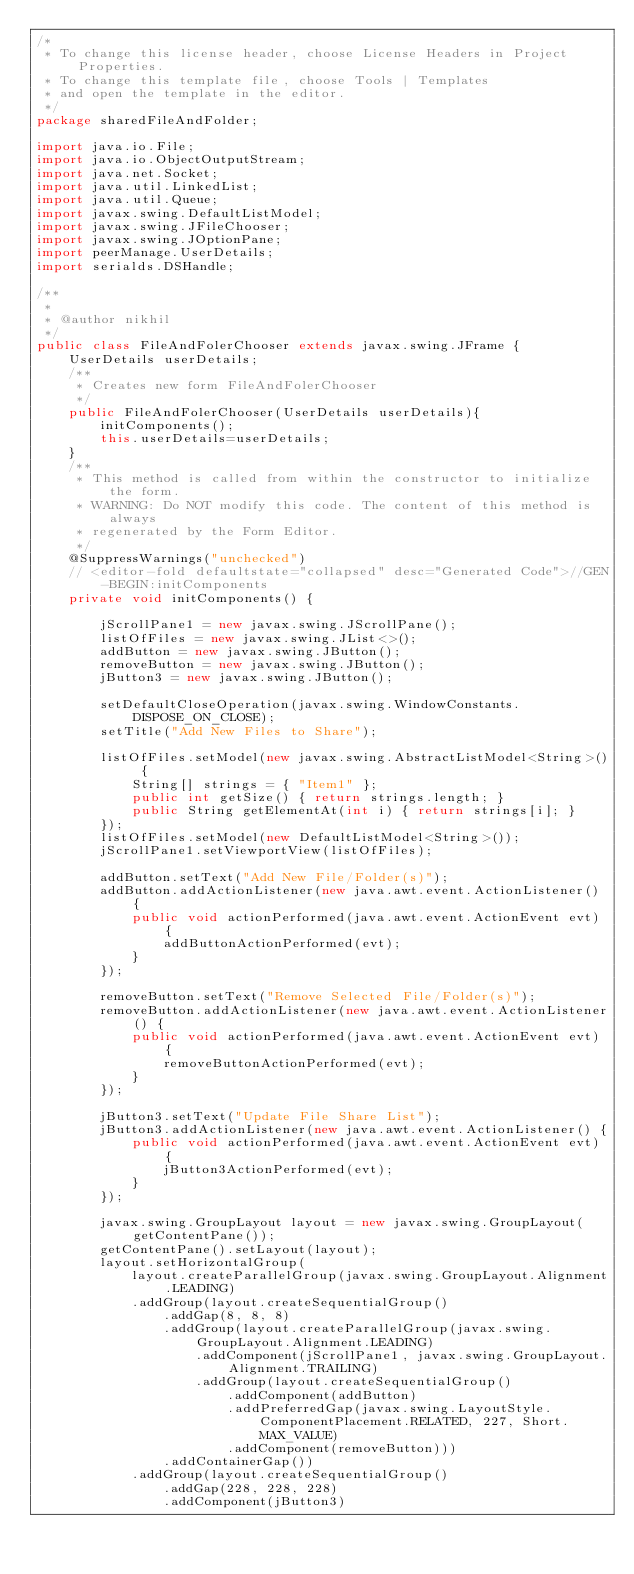Convert code to text. <code><loc_0><loc_0><loc_500><loc_500><_Java_>/*
 * To change this license header, choose License Headers in Project Properties.
 * To change this template file, choose Tools | Templates
 * and open the template in the editor.
 */
package sharedFileAndFolder;

import java.io.File;
import java.io.ObjectOutputStream;
import java.net.Socket;
import java.util.LinkedList;
import java.util.Queue;
import javax.swing.DefaultListModel;
import javax.swing.JFileChooser;
import javax.swing.JOptionPane;
import peerManage.UserDetails;
import serialds.DSHandle;

/**
 *
 * @author nikhil
 */
public class FileAndFolerChooser extends javax.swing.JFrame {
    UserDetails userDetails;
    /**
     * Creates new form FileAndFolerChooser
     */
    public FileAndFolerChooser(UserDetails userDetails){
        initComponents();
        this.userDetails=userDetails;
    }
    /**
     * This method is called from within the constructor to initialize the form.
     * WARNING: Do NOT modify this code. The content of this method is always
     * regenerated by the Form Editor.
     */
    @SuppressWarnings("unchecked")
    // <editor-fold defaultstate="collapsed" desc="Generated Code">//GEN-BEGIN:initComponents
    private void initComponents() {

        jScrollPane1 = new javax.swing.JScrollPane();
        listOfFiles = new javax.swing.JList<>();
        addButton = new javax.swing.JButton();
        removeButton = new javax.swing.JButton();
        jButton3 = new javax.swing.JButton();

        setDefaultCloseOperation(javax.swing.WindowConstants.DISPOSE_ON_CLOSE);
        setTitle("Add New Files to Share");

        listOfFiles.setModel(new javax.swing.AbstractListModel<String>() {
            String[] strings = { "Item1" };
            public int getSize() { return strings.length; }
            public String getElementAt(int i) { return strings[i]; }
        });
        listOfFiles.setModel(new DefaultListModel<String>());
        jScrollPane1.setViewportView(listOfFiles);

        addButton.setText("Add New File/Folder(s)");
        addButton.addActionListener(new java.awt.event.ActionListener() {
            public void actionPerformed(java.awt.event.ActionEvent evt) {
                addButtonActionPerformed(evt);
            }
        });

        removeButton.setText("Remove Selected File/Folder(s)");
        removeButton.addActionListener(new java.awt.event.ActionListener() {
            public void actionPerformed(java.awt.event.ActionEvent evt) {
                removeButtonActionPerformed(evt);
            }
        });

        jButton3.setText("Update File Share List");
        jButton3.addActionListener(new java.awt.event.ActionListener() {
            public void actionPerformed(java.awt.event.ActionEvent evt) {
                jButton3ActionPerformed(evt);
            }
        });

        javax.swing.GroupLayout layout = new javax.swing.GroupLayout(getContentPane());
        getContentPane().setLayout(layout);
        layout.setHorizontalGroup(
            layout.createParallelGroup(javax.swing.GroupLayout.Alignment.LEADING)
            .addGroup(layout.createSequentialGroup()
                .addGap(8, 8, 8)
                .addGroup(layout.createParallelGroup(javax.swing.GroupLayout.Alignment.LEADING)
                    .addComponent(jScrollPane1, javax.swing.GroupLayout.Alignment.TRAILING)
                    .addGroup(layout.createSequentialGroup()
                        .addComponent(addButton)
                        .addPreferredGap(javax.swing.LayoutStyle.ComponentPlacement.RELATED, 227, Short.MAX_VALUE)
                        .addComponent(removeButton)))
                .addContainerGap())
            .addGroup(layout.createSequentialGroup()
                .addGap(228, 228, 228)
                .addComponent(jButton3)</code> 